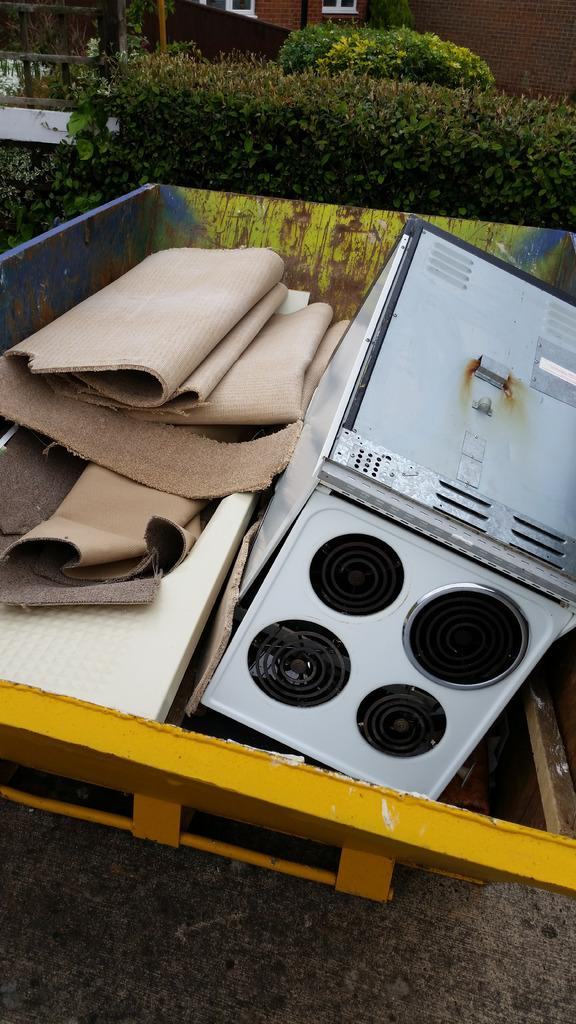What can be seen in the image? There are objects and trees in the image. Can you describe the building in the background? There is a building with windows in the background of the image. Where is the lamp located in the image? There is no lamp present in the image. What type of patch can be seen on the trees in the image? There are no patches visible on the trees in the image. 